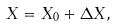Convert formula to latex. <formula><loc_0><loc_0><loc_500><loc_500>X = X _ { 0 } + \Delta X ,</formula> 